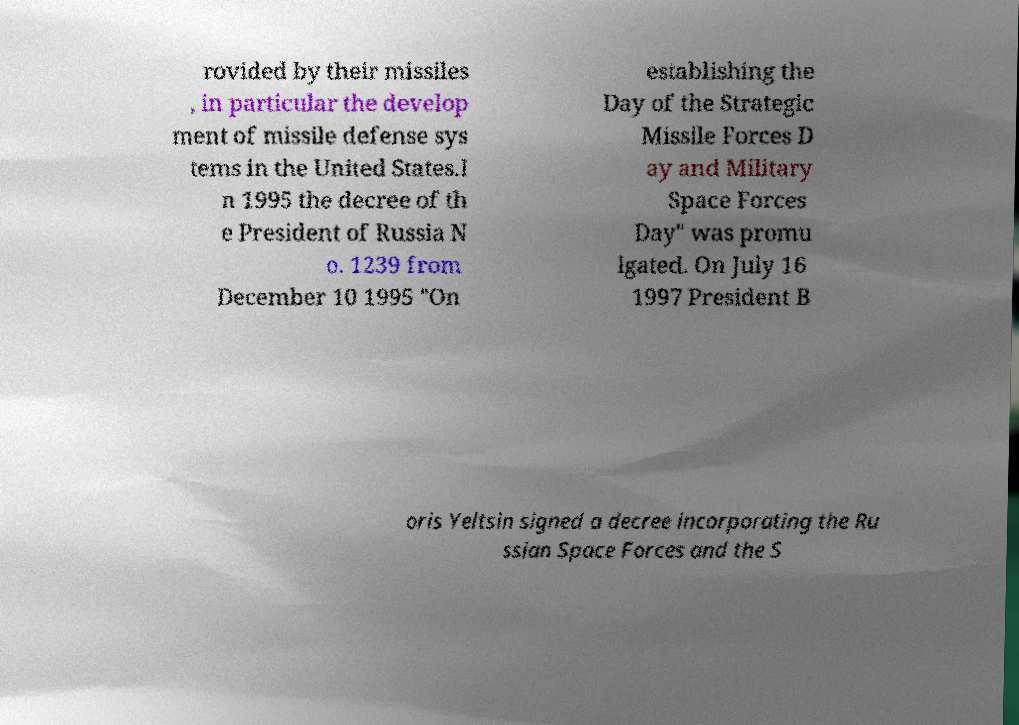Can you read and provide the text displayed in the image?This photo seems to have some interesting text. Can you extract and type it out for me? rovided by their missiles , in particular the develop ment of missile defense sys tems in the United States.I n 1995 the decree of th e President of Russia N o. 1239 from December 10 1995 "On establishing the Day of the Strategic Missile Forces D ay and Military Space Forces Day" was promu lgated. On July 16 1997 President B oris Yeltsin signed a decree incorporating the Ru ssian Space Forces and the S 